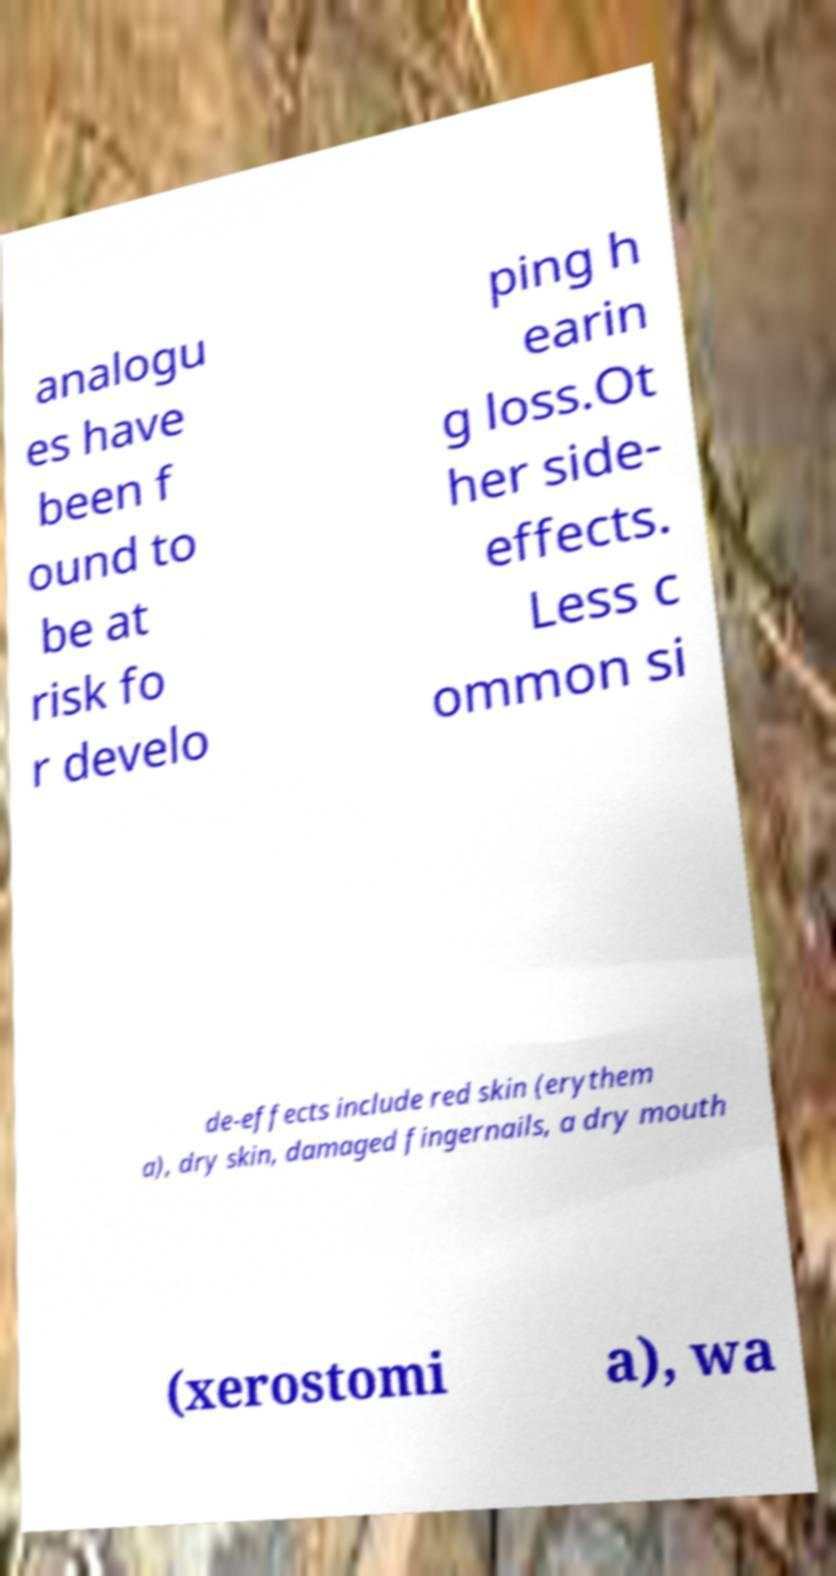For documentation purposes, I need the text within this image transcribed. Could you provide that? analogu es have been f ound to be at risk fo r develo ping h earin g loss.Ot her side- effects. Less c ommon si de-effects include red skin (erythem a), dry skin, damaged fingernails, a dry mouth (xerostomi a), wa 